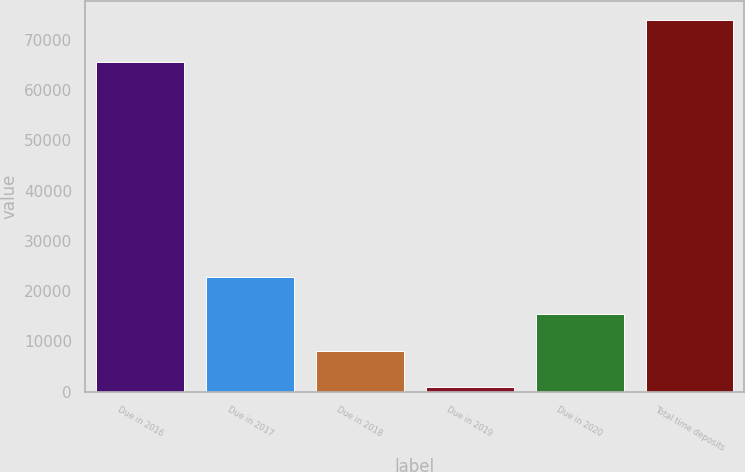<chart> <loc_0><loc_0><loc_500><loc_500><bar_chart><fcel>Due in 2016<fcel>Due in 2017<fcel>Due in 2018<fcel>Due in 2019<fcel>Due in 2020<fcel>Total time deposits<nl><fcel>65567<fcel>22807.5<fcel>8188.5<fcel>879<fcel>15498<fcel>73974<nl></chart> 